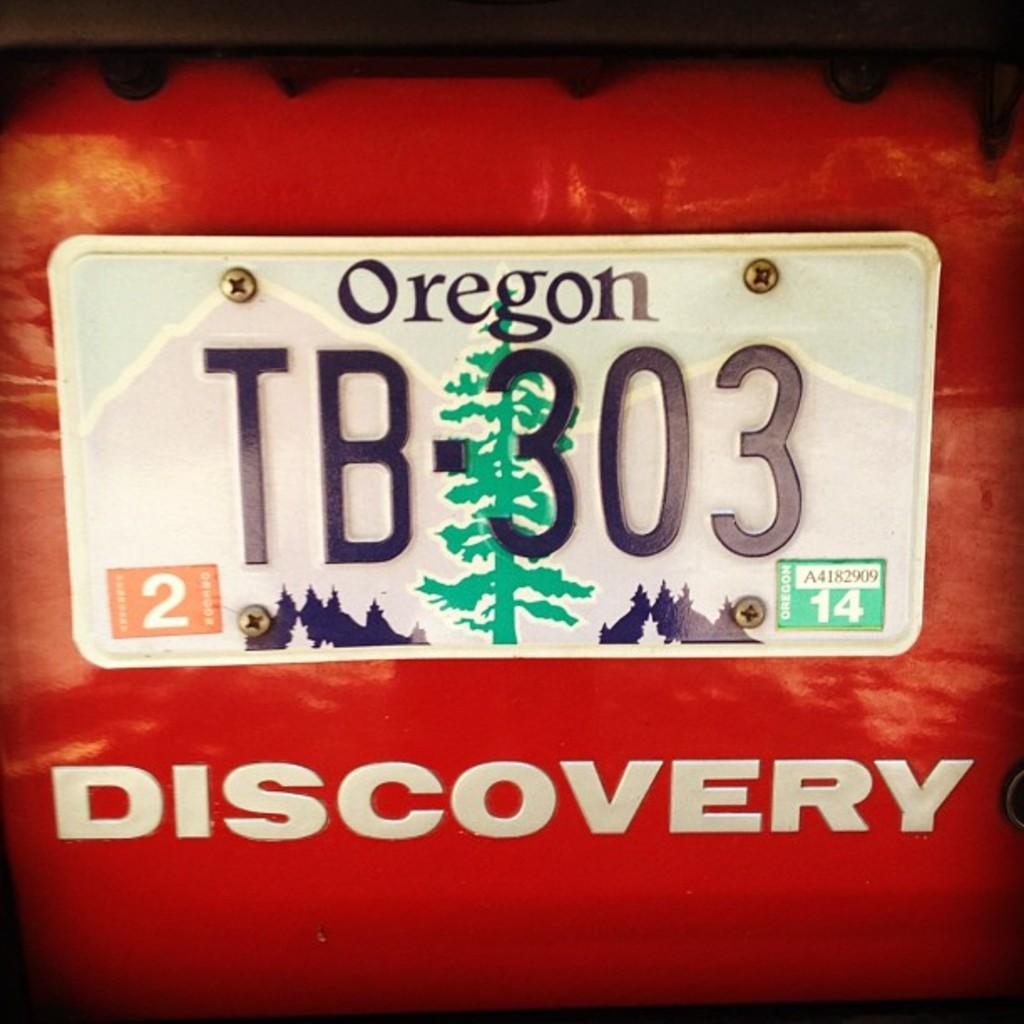What state is the license plate for?
Make the answer very short. Oregon. What is the number on the green sticker?
Provide a succinct answer. 14. 